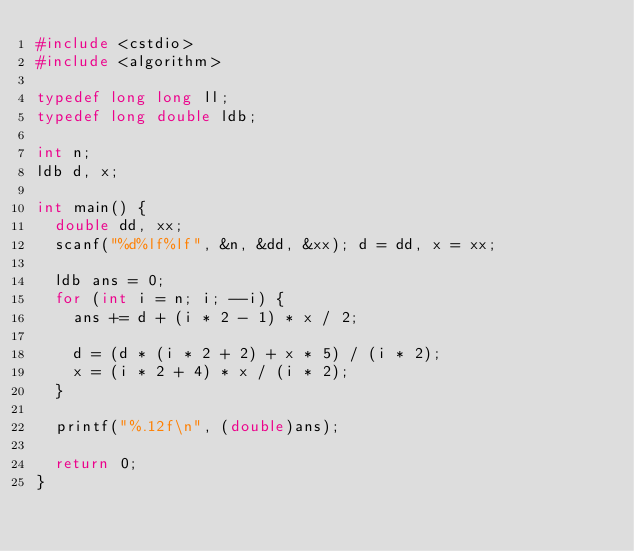<code> <loc_0><loc_0><loc_500><loc_500><_C++_>#include <cstdio>
#include <algorithm>

typedef long long ll;
typedef long double ldb;

int n;
ldb d, x;

int main() {
	double dd, xx;
	scanf("%d%lf%lf", &n, &dd, &xx); d = dd, x = xx;
	
	ldb ans = 0;
	for (int i = n; i; --i) {
		ans += d + (i * 2 - 1) * x / 2;
		
		d = (d * (i * 2 + 2) + x * 5) / (i * 2);
		x = (i * 2 + 4) * x / (i * 2);
	}
	
	printf("%.12f\n", (double)ans);
	
	return 0;
}
</code> 